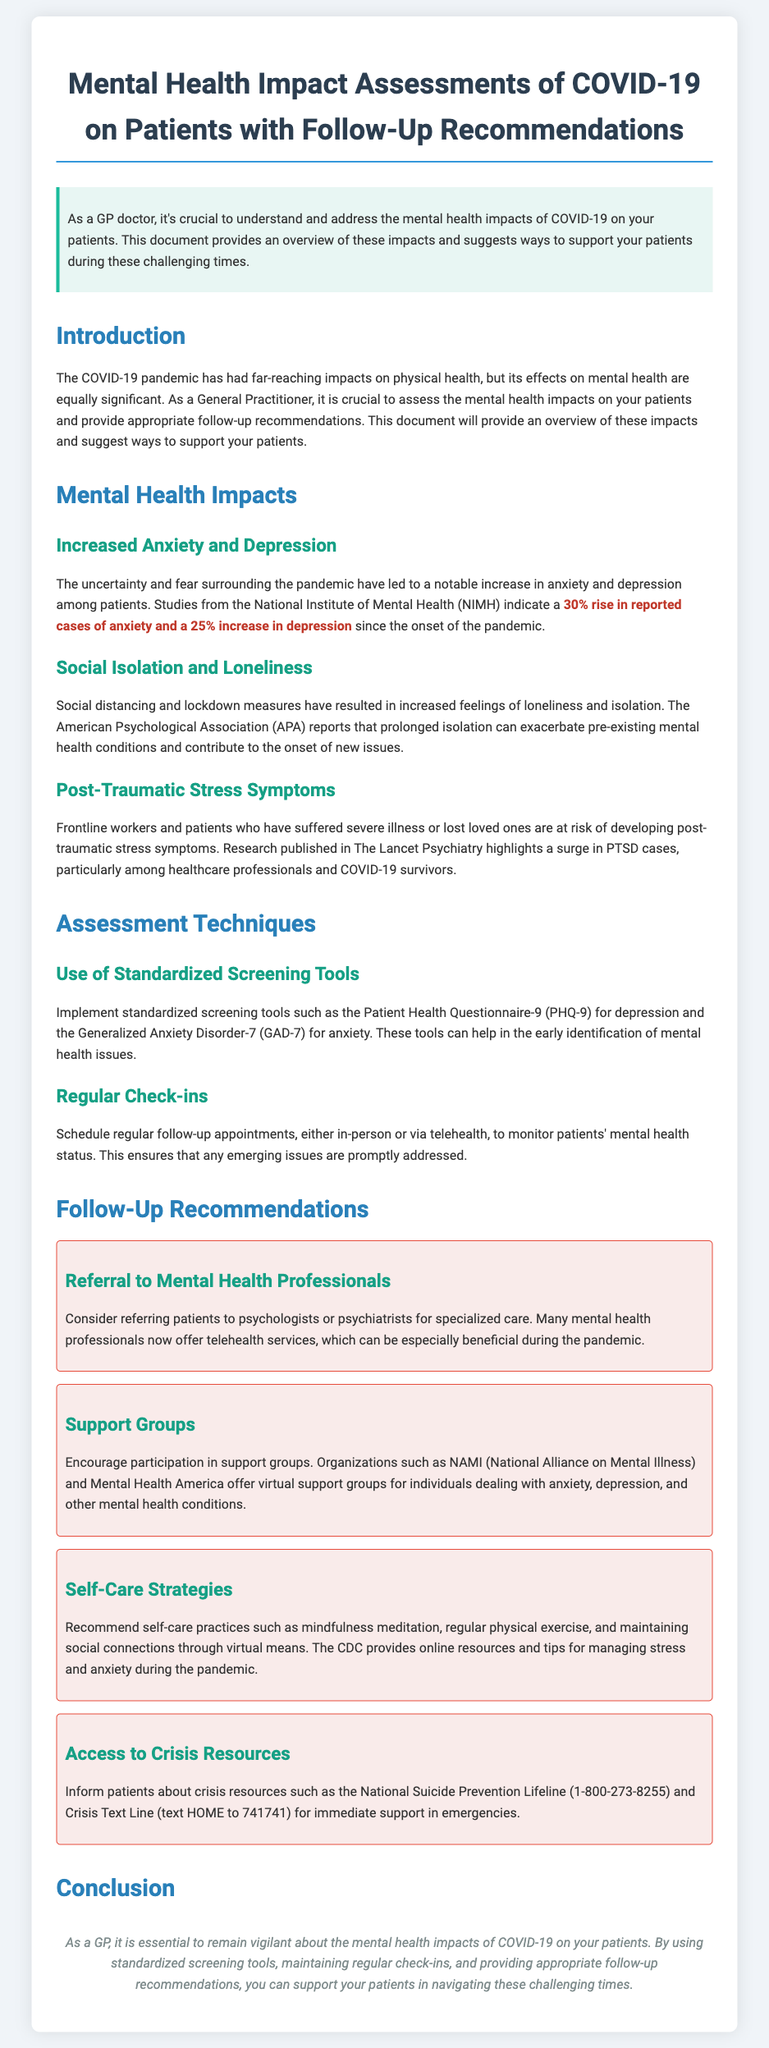What is the primary focus of this document? The document primarily focuses on assessing the mental health impacts of COVID-19 on patients and providing follow-up recommendations.
Answer: Mental health impacts of COVID-19 What percentage increase in anxiety cases is reported? The document states that there has been a 30% rise in reported cases of anxiety since the onset of the pandemic.
Answer: 30% What screening tools are suggested for assessing mental health? The document recommends the Patient Health Questionnaire-9 (PHQ-9) for depression and the Generalized Anxiety Disorder-7 (GAD-7) for anxiety as standardized screening tools.
Answer: PHQ-9 and GAD-7 Which organization offers virtual support groups? The National Alliance on Mental Illness (NAMI) is mentioned as an organization providing virtual support groups.
Answer: NAMI What is one recommended self-care strategy? The document suggests mindfulness meditation as one of the self-care practices.
Answer: Mindfulness meditation What is a key reason for the increased feelings of loneliness and isolation? Prolonged isolation due to social distancing and lockdown measures is a key reason for increased loneliness.
Answer: Social distancing and lockdown measures What is a resource for immediate support in emergencies? The National Suicide Prevention Lifeline (1-800-273-8255) is listed as a crisis resource for immediate support.
Answer: National Suicide Prevention Lifeline What type of professionals may patients be referred to? Patients may be referred to psychologists or psychiatrists for specialized care.
Answer: Psychologists or psychiatrists 